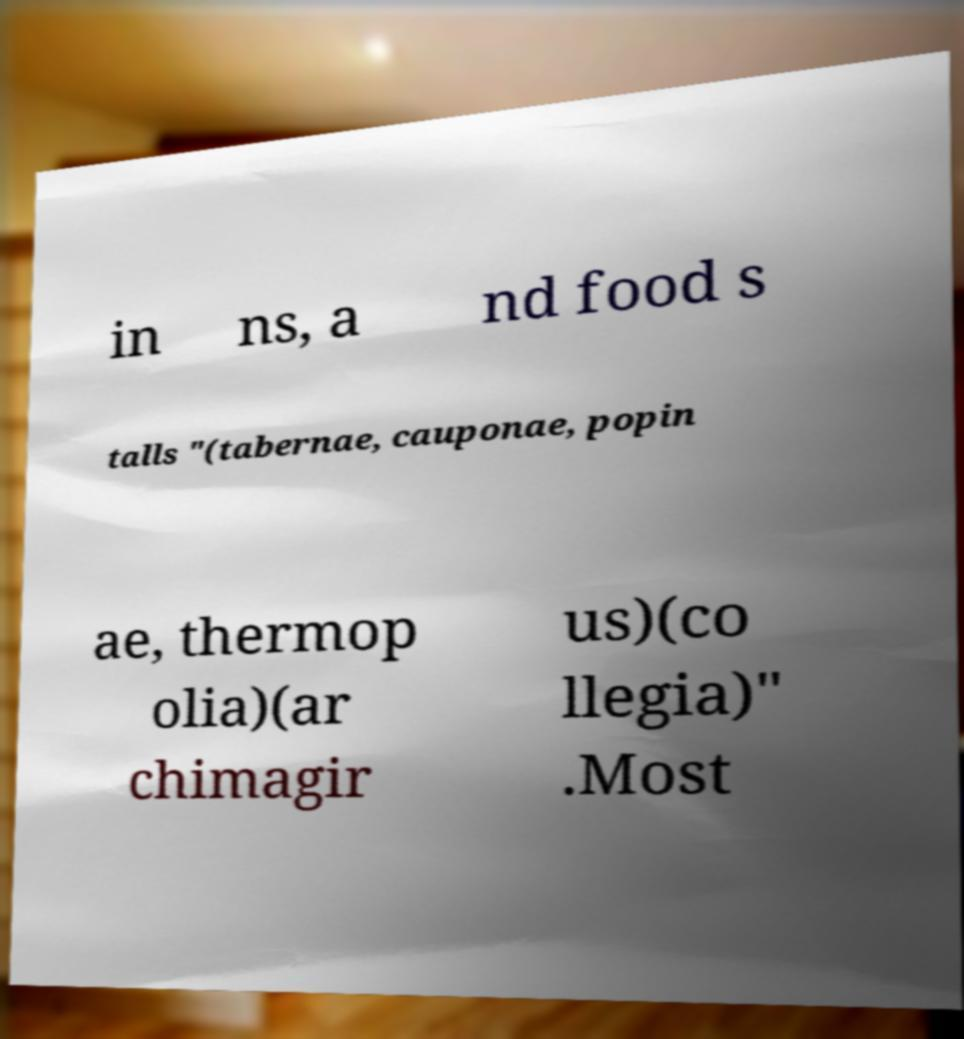What messages or text are displayed in this image? I need them in a readable, typed format. in ns, a nd food s talls "(tabernae, cauponae, popin ae, thermop olia)(ar chimagir us)(co llegia)" .Most 